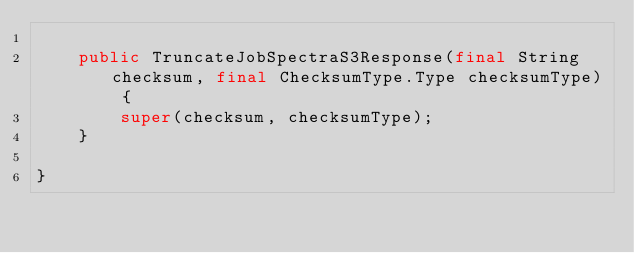Convert code to text. <code><loc_0><loc_0><loc_500><loc_500><_Java_>    
    public TruncateJobSpectraS3Response(final String checksum, final ChecksumType.Type checksumType) {
        super(checksum, checksumType);
    }

}</code> 